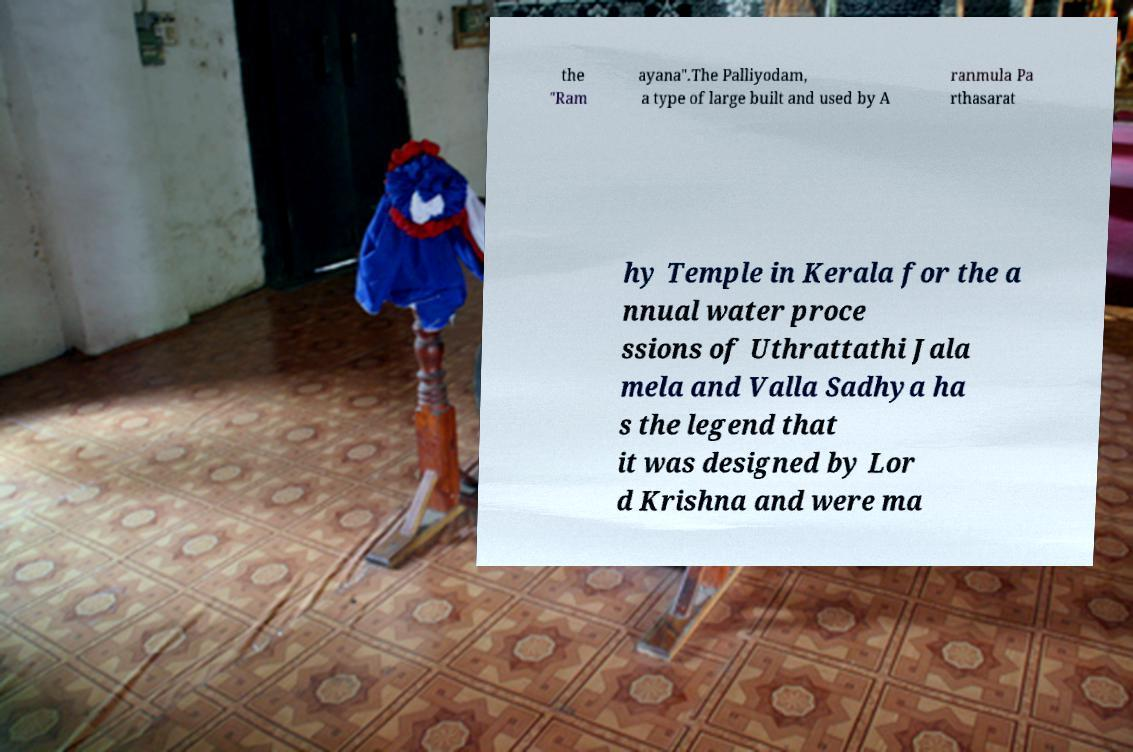I need the written content from this picture converted into text. Can you do that? the "Ram ayana".The Palliyodam, a type of large built and used by A ranmula Pa rthasarat hy Temple in Kerala for the a nnual water proce ssions of Uthrattathi Jala mela and Valla Sadhya ha s the legend that it was designed by Lor d Krishna and were ma 